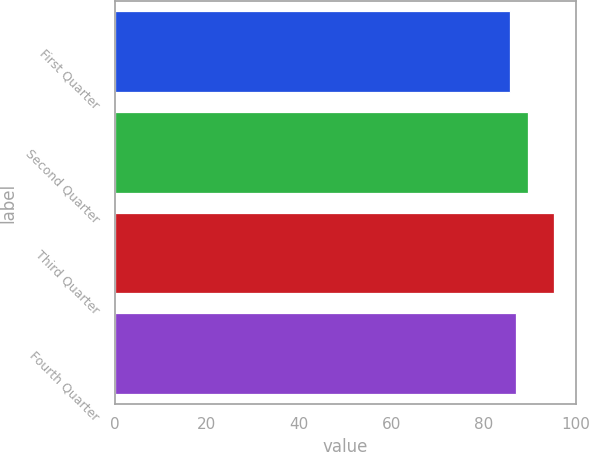Convert chart. <chart><loc_0><loc_0><loc_500><loc_500><bar_chart><fcel>First Quarter<fcel>Second Quarter<fcel>Third Quarter<fcel>Fourth Quarter<nl><fcel>85.8<fcel>89.68<fcel>95.36<fcel>87.01<nl></chart> 